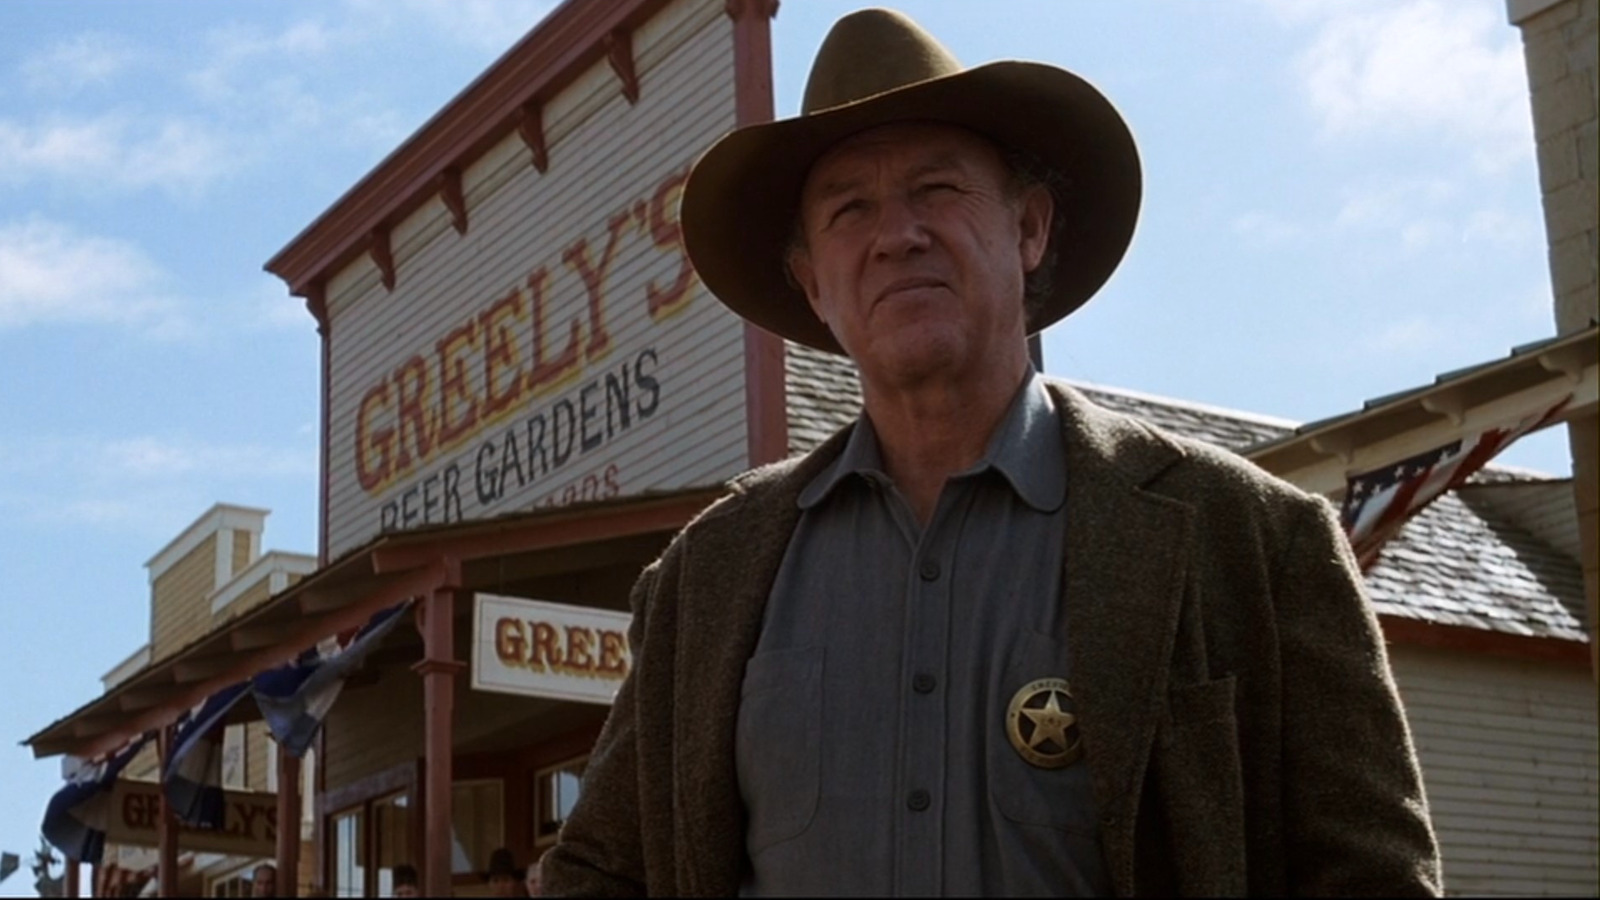What details can you gather about the setting of the scene in this image? The setting of the scene takes place outside a saloon named 'Greenly's Beer Gardens', which suggests a social gathering spot typical of Western films. The saloon's facade is adorned with bunting, likely indicating a festive or significant day in the plot. The arid landscape visible in the background adds to the typical old West town ambiance, suggesting a sense of isolation or frontier challenge. Can you guess what period the attire might suggest? The attire worn by Gene Hackman is indicative of the late 19th century, commonly represented in Westerns. His broad-brimmed hat, tweed jacket, and sturdy shirt all reflect the practical and rugged clothing of that period, designed to be suitable for rough outdoor environments and align with the utilitarian lifestyle of that era. 